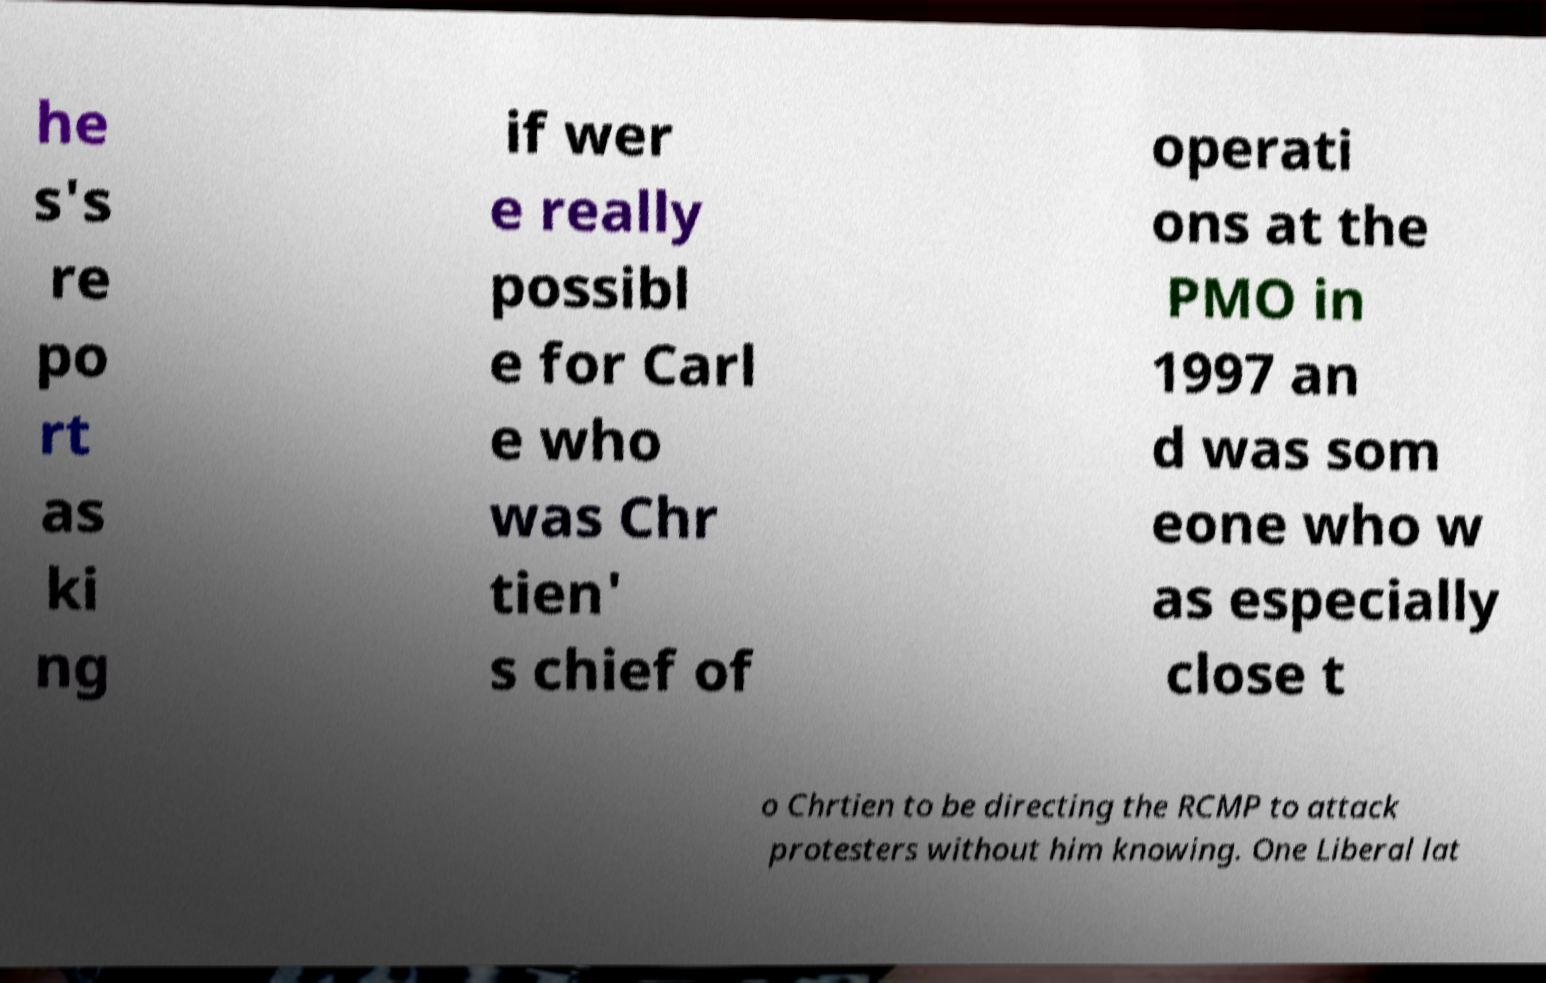Could you assist in decoding the text presented in this image and type it out clearly? he s's re po rt as ki ng if wer e really possibl e for Carl e who was Chr tien' s chief of operati ons at the PMO in 1997 an d was som eone who w as especially close t o Chrtien to be directing the RCMP to attack protesters without him knowing. One Liberal lat 